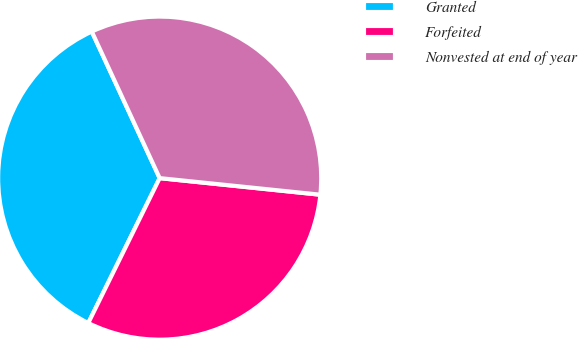<chart> <loc_0><loc_0><loc_500><loc_500><pie_chart><fcel>Granted<fcel>Forfeited<fcel>Nonvested at end of year<nl><fcel>35.81%<fcel>30.65%<fcel>33.54%<nl></chart> 